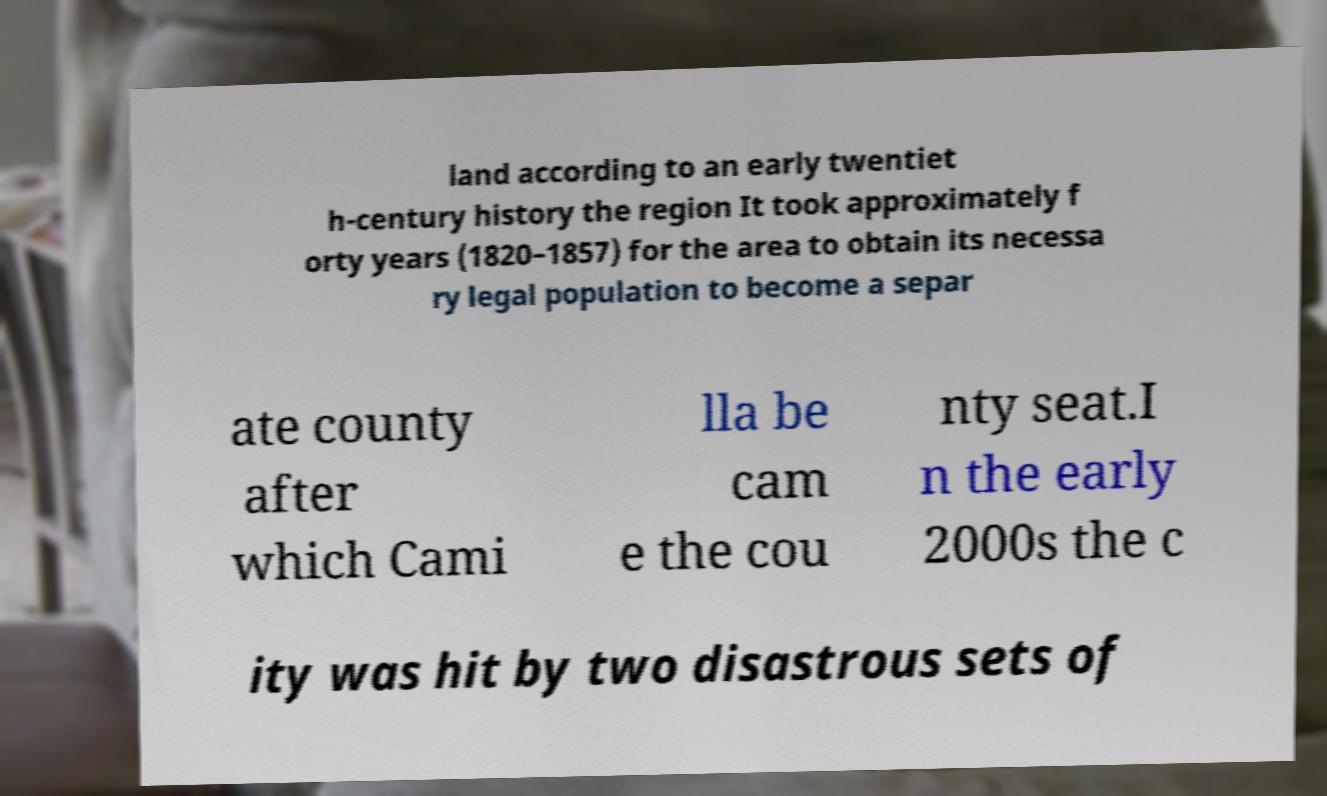There's text embedded in this image that I need extracted. Can you transcribe it verbatim? land according to an early twentiet h-century history the region It took approximately f orty years (1820–1857) for the area to obtain its necessa ry legal population to become a separ ate county after which Cami lla be cam e the cou nty seat.I n the early 2000s the c ity was hit by two disastrous sets of 